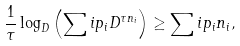Convert formula to latex. <formula><loc_0><loc_0><loc_500><loc_500>\frac { 1 } { \tau } \log _ { D } \left ( \sum i p _ { i } D ^ { \tau n _ { i } } \right ) \geq \sum i p _ { i } n _ { i } ,</formula> 